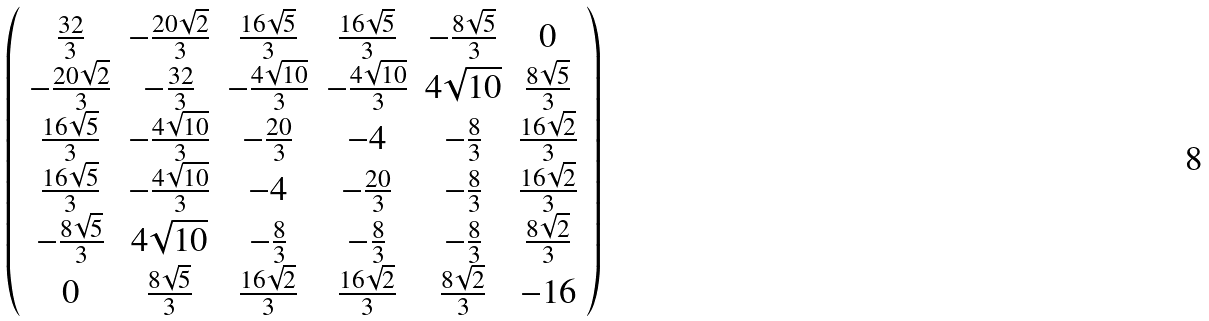Convert formula to latex. <formula><loc_0><loc_0><loc_500><loc_500>\left ( \begin{array} { c c c c c c } \frac { 3 2 } { 3 } & - \frac { 2 0 \sqrt { 2 } } { 3 } & \frac { 1 6 \sqrt { 5 } } { 3 } & \frac { 1 6 \sqrt { 5 } } { 3 } & - \frac { 8 \sqrt { 5 } } { 3 } & 0 \\ - \frac { 2 0 \sqrt { 2 } } { 3 } & - \frac { 3 2 } { 3 } & - \frac { 4 \sqrt { 1 0 } } { 3 } & - \frac { 4 \sqrt { 1 0 } } { 3 } & 4 \sqrt { 1 0 } & \frac { 8 \sqrt { 5 } } { 3 } \\ \frac { 1 6 \sqrt { 5 } } { 3 } & - \frac { 4 \sqrt { 1 0 } } { 3 } & - \frac { 2 0 } { 3 } & - 4 & - \frac { 8 } { 3 } & \frac { 1 6 \sqrt { 2 } } { 3 } \\ \frac { 1 6 \sqrt { 5 } } { 3 } & - \frac { 4 \sqrt { 1 0 } } { 3 } & - 4 & - \frac { 2 0 } { 3 } & - \frac { 8 } { 3 } & \frac { 1 6 \sqrt { 2 } } { 3 } \\ - \frac { 8 \sqrt { 5 } } { 3 } & 4 \sqrt { 1 0 } & - \frac { 8 } { 3 } & - \frac { 8 } { 3 } & - \frac { 8 } { 3 } & \frac { 8 \sqrt { 2 } } { 3 } \\ 0 & \frac { 8 \sqrt { 5 } } { 3 } & \frac { 1 6 \sqrt { 2 } } { 3 } & \frac { 1 6 \sqrt { 2 } } { 3 } & \frac { 8 \sqrt { 2 } } { 3 } & - 1 6 \end{array} \right )</formula> 